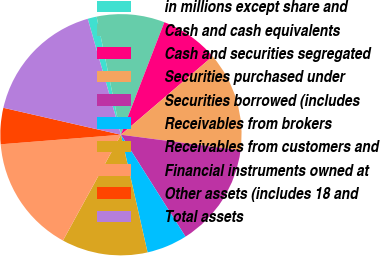<chart> <loc_0><loc_0><loc_500><loc_500><pie_chart><fcel>in millions except share and<fcel>Cash and cash equivalents<fcel>Cash and securities segregated<fcel>Securities purchased under<fcel>Securities borrowed (includes<fcel>Receivables from brokers<fcel>Receivables from customers and<fcel>Financial instruments owned at<fcel>Other assets (includes 18 and<fcel>Total assets<nl><fcel>1.21%<fcel>9.09%<fcel>7.88%<fcel>13.33%<fcel>13.94%<fcel>5.45%<fcel>11.52%<fcel>15.76%<fcel>4.85%<fcel>16.97%<nl></chart> 